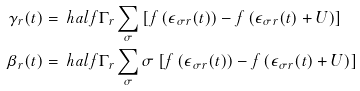<formula> <loc_0><loc_0><loc_500><loc_500>\gamma _ { r } ( t ) & = { \ h a l f } \Gamma _ { r } \sum _ { \sigma } \left [ f \left ( \epsilon _ { \sigma r } ( t ) \right ) - f \left ( \epsilon _ { \sigma r } ( t ) + U \right ) \right ] \\ \beta _ { r } ( t ) & = { \ h a l f } \Gamma _ { r } \sum _ { \sigma } \sigma \left [ f \left ( \epsilon _ { \sigma r } ( t ) \right ) - f \left ( \epsilon _ { \sigma r } ( t ) + U \right ) \right ]</formula> 